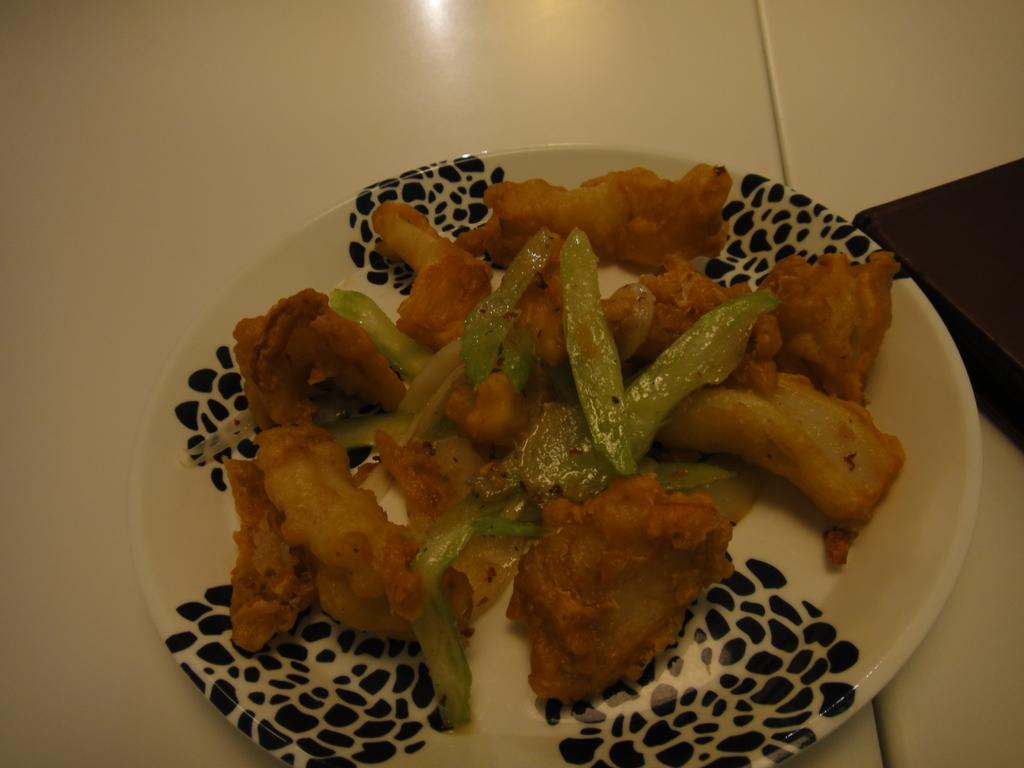What piece of furniture is present in the image? There is a table in the image. What is placed on the table? There is a plate on the table. What is on the plate? There are food items in the plate. What object is located near the table? There is a box at the side of the table. What type of kite is being used to prepare the stew in the image? There is no kite or stew present in the image; it features a table with a plate of food and a box nearby. 